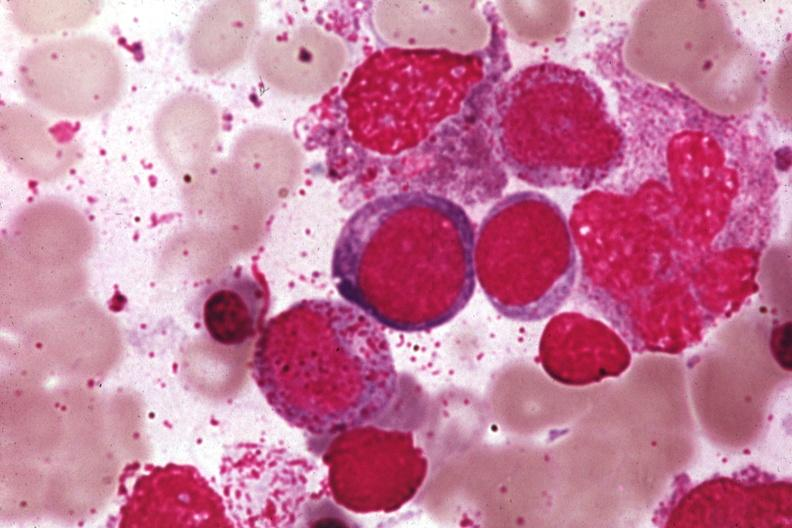what is present?
Answer the question using a single word or phrase. Megaloblasts pernicious anemia 